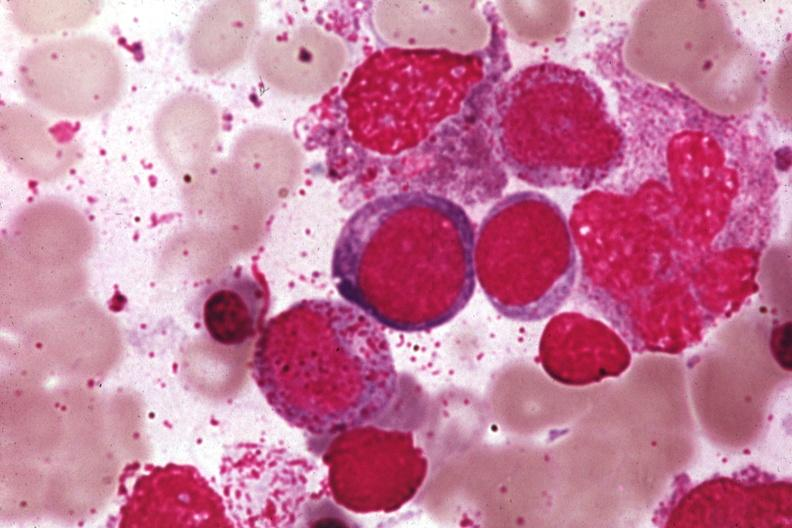what is present?
Answer the question using a single word or phrase. Megaloblasts pernicious anemia 